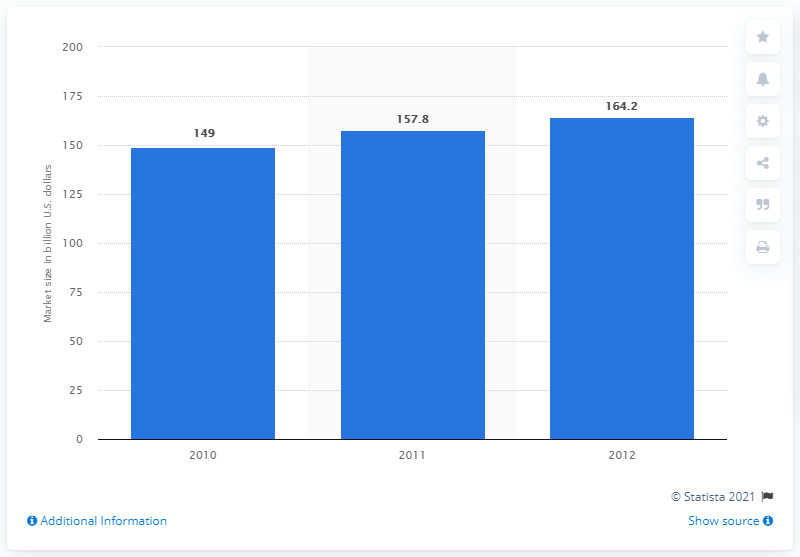Outline some significant characteristics in this image. The global market size for notebooks is expected to reach 164.2 million units by 2012. 